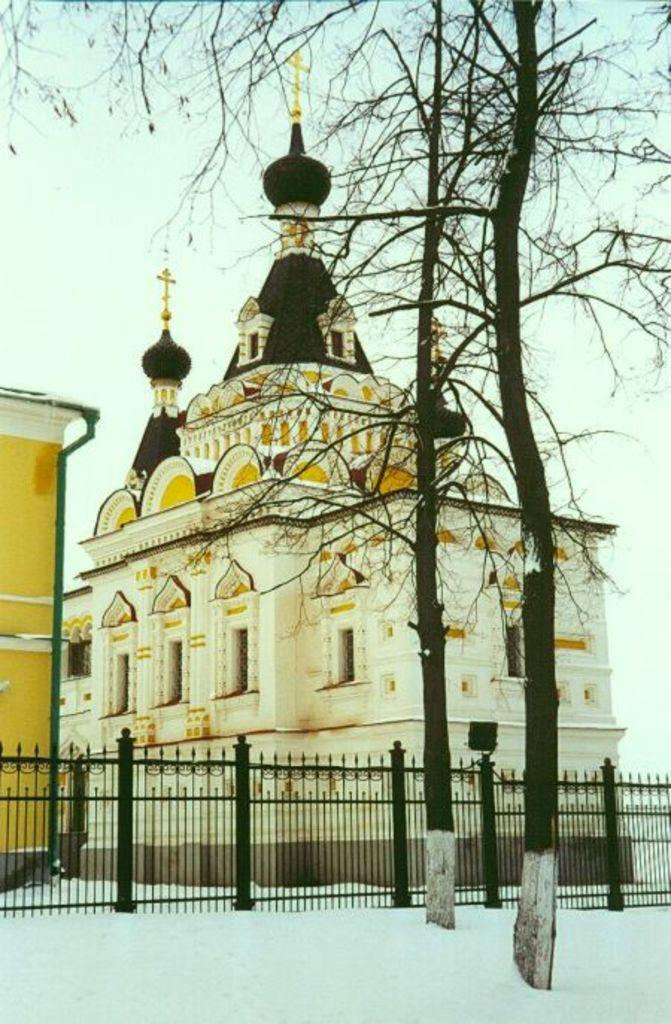What is located in the center of the image? There are buildings in the center of the image. What can be seen at the bottom of the image? There is a fence and snow at the bottom of the image. What type of vegetation is present in the image? There are trees in the image. What is visible in the background of the image? The sky is visible in the background of the image. Can you tell me how many chess pieces are on the ground in the image? There are no chess pieces present in the image. What type of animal can be seen in the zoo in the image? There is no zoo present in the image. 